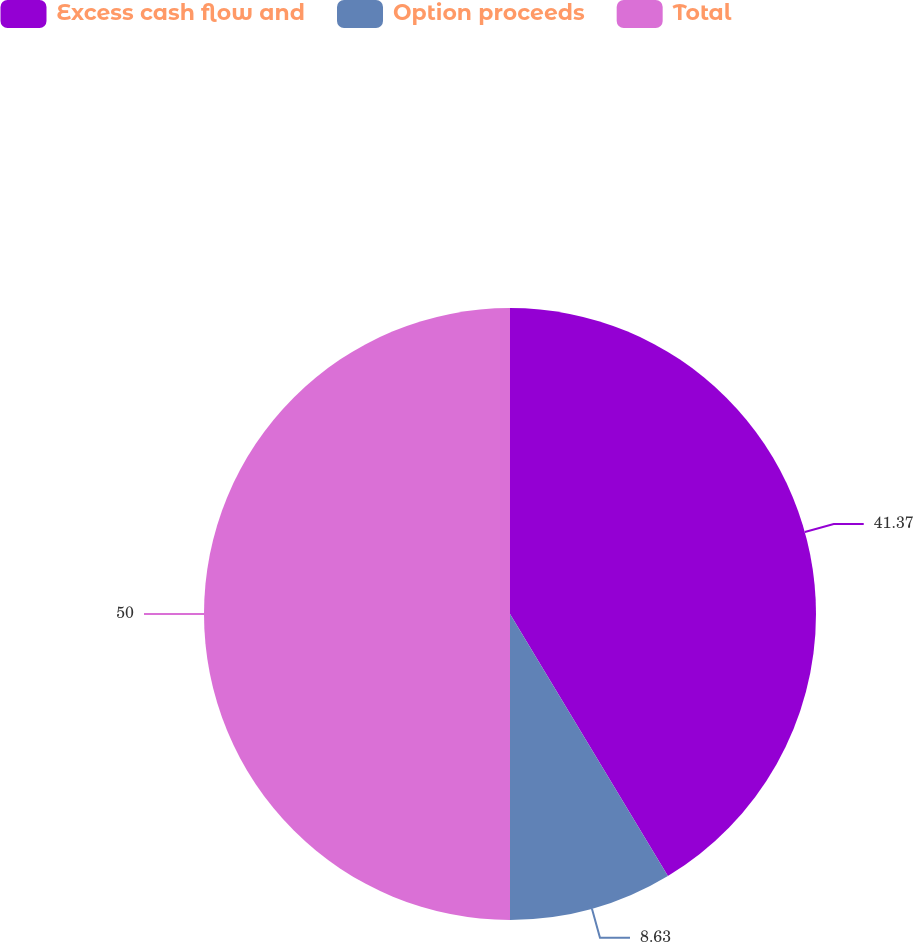Convert chart. <chart><loc_0><loc_0><loc_500><loc_500><pie_chart><fcel>Excess cash flow and<fcel>Option proceeds<fcel>Total<nl><fcel>41.37%<fcel>8.63%<fcel>50.0%<nl></chart> 